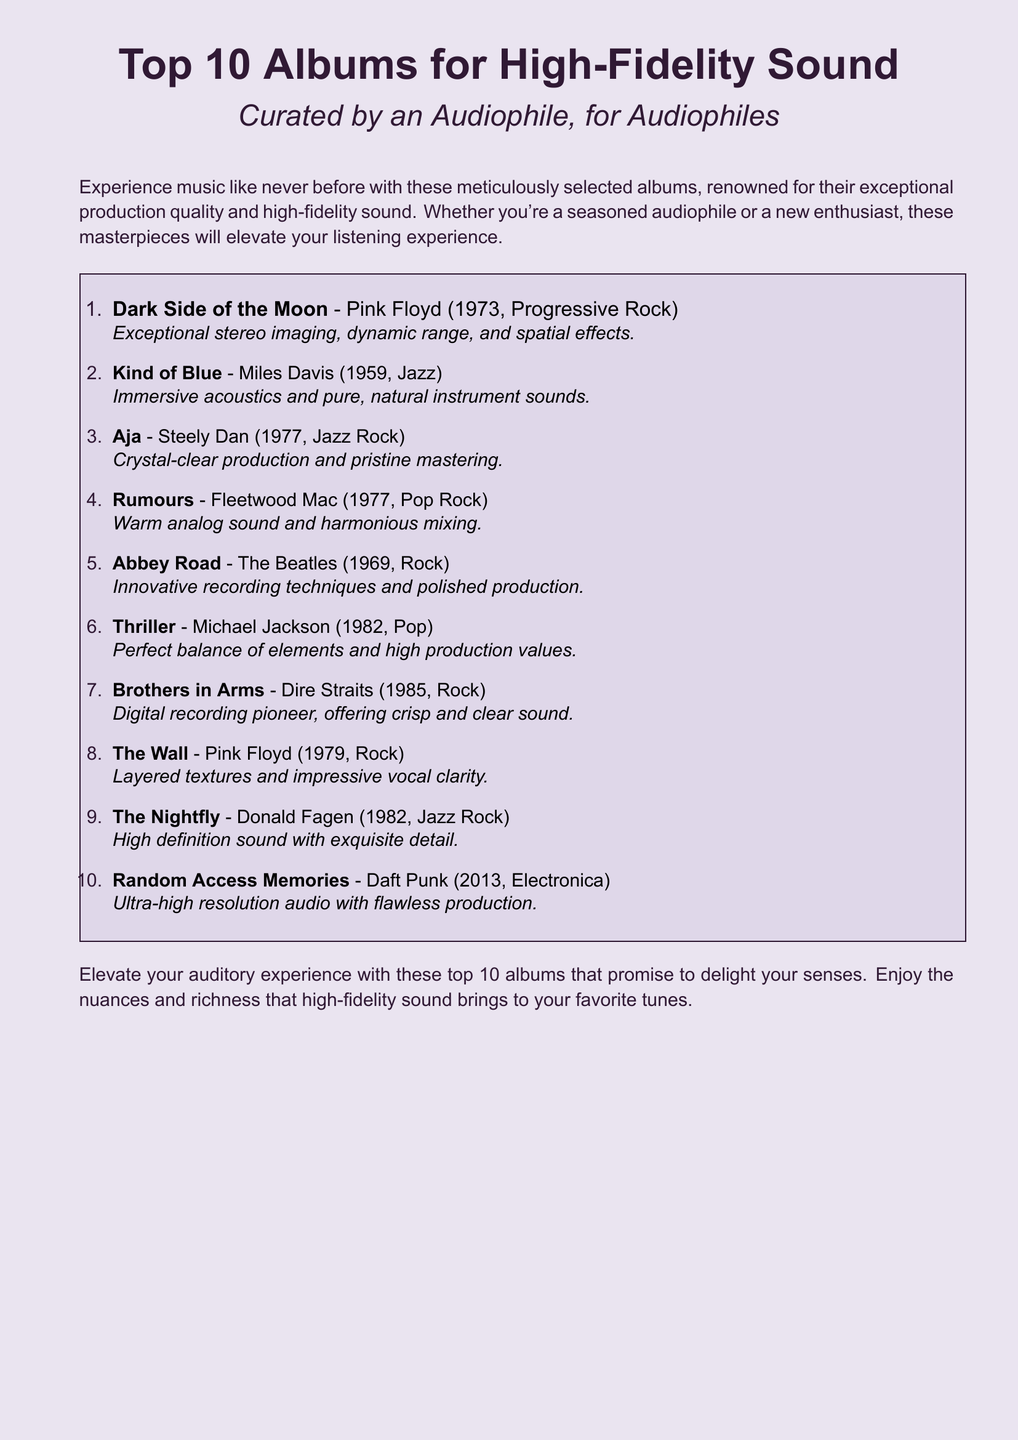What is the first album listed? The first album in the list is "Dark Side of the Moon" by Pink Floyd.
Answer: Dark Side of the Moon Who is the artist of "Kind of Blue"? "Kind of Blue" is an album by Miles Davis.
Answer: Miles Davis In what year was "Thriller" released? "Thriller" was released in 1982.
Answer: 1982 Which genre is "Abbey Road" categorized under? "Abbey Road" is categorized under Rock.
Answer: Rock What is noted about the production of "Aja"? The document mentions that "Aja" has crystal-clear production and pristine mastering.
Answer: Crystal-clear production and pristine mastering How many albums on the list are categorized as Jazz? There are three albums categorized as Jazz on the list.
Answer: 3 What common element is highlighted across all the albums? The document emphasizes high-fidelity sound quality across all the albums.
Answer: High-fidelity sound quality Which album is the latest one mentioned in the list? The latest album mentioned is "Random Access Memories" released in 2013.
Answer: Random Access Memories What type of sound does "The Nightfly" offer? "The Nightfly" offers high definition sound with exquisite detail.
Answer: High definition sound with exquisite detail 